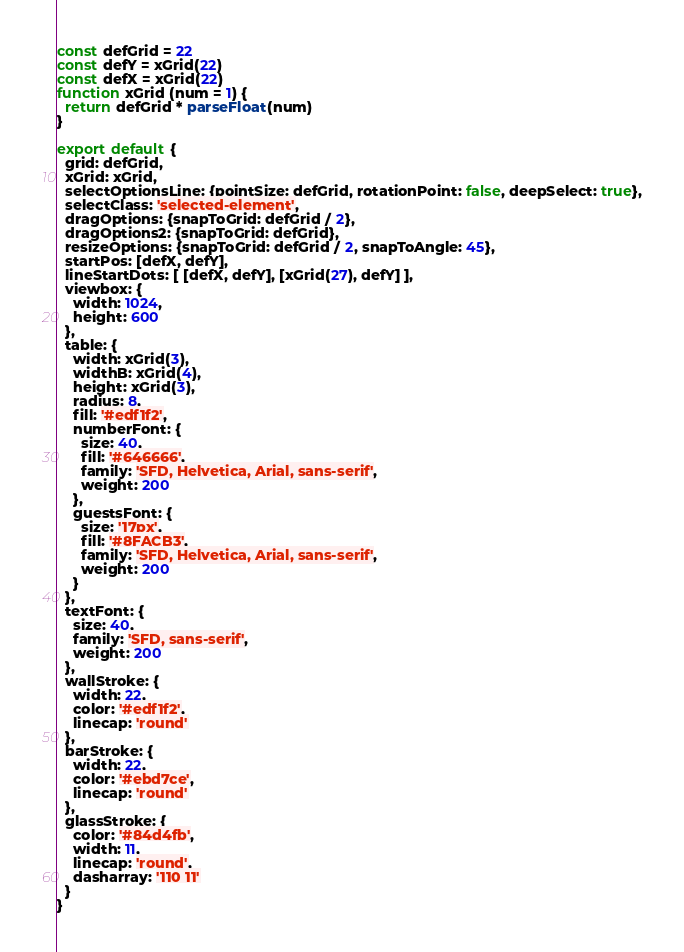Convert code to text. <code><loc_0><loc_0><loc_500><loc_500><_JavaScript_>const defGrid = 22
const defY = xGrid(22)
const defX = xGrid(22)
function xGrid (num = 1) {
  return defGrid * parseFloat(num)
}

export default {
  grid: defGrid,
  xGrid: xGrid,
  selectOptionsLine: {pointSize: defGrid, rotationPoint: false, deepSelect: true},
  selectClass: 'selected-element',
  dragOptions: {snapToGrid: defGrid / 2},
  dragOptions2: {snapToGrid: defGrid},
  resizeOptions: {snapToGrid: defGrid / 2, snapToAngle: 45},
  startPos: [defX, defY],
  lineStartDots: [ [defX, defY], [xGrid(27), defY] ],
  viewbox: {
    width: 1024,
    height: 600
  },
  table: {
    width: xGrid(3),
    widthB: xGrid(4),
    height: xGrid(3),
    radius: 8,
    fill: '#edf1f2',
    numberFont: {
      size: 40,
      fill: '#646666',
      family: 'SFD, Helvetica, Arial, sans-serif',
      weight: 200
    },
    guestsFont: {
      size: '17px',
      fill: '#8FACB3',
      family: 'SFD, Helvetica, Arial, sans-serif',
      weight: 200
    }
  },
  textFont: {
    size: 40,
    family: 'SFD, sans-serif',
    weight: 200
  },
  wallStroke: {
    width: 22,
    color: '#edf1f2',
    linecap: 'round'
  },
  barStroke: {
    width: 22,
    color: '#ebd7ce',
    linecap: 'round'
  },
  glassStroke: {
    color: '#84d4fb',
    width: 11,
    linecap: 'round',
    dasharray: '110 11'
  }
}
</code> 